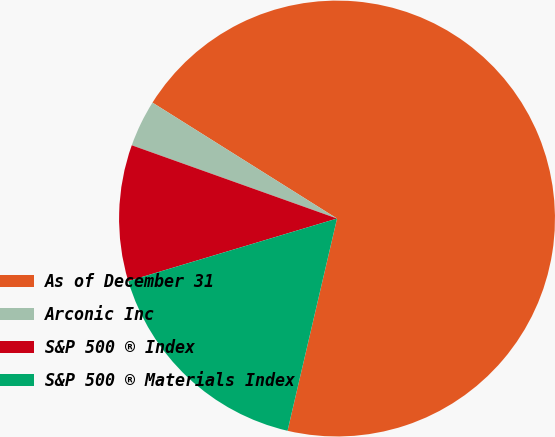Convert chart. <chart><loc_0><loc_0><loc_500><loc_500><pie_chart><fcel>As of December 31<fcel>Arconic Inc<fcel>S&P 500 ® Index<fcel>S&P 500 ® Materials Index<nl><fcel>69.72%<fcel>3.47%<fcel>10.09%<fcel>16.72%<nl></chart> 